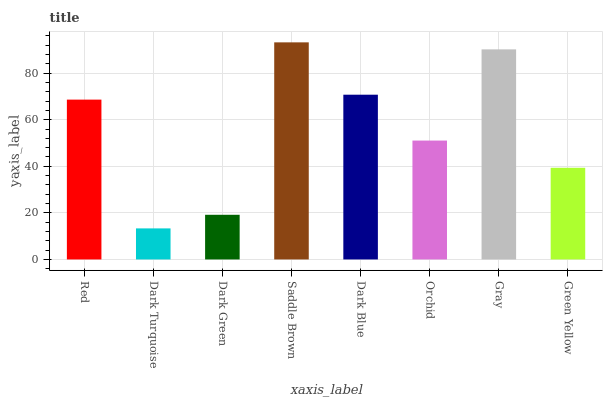Is Dark Turquoise the minimum?
Answer yes or no. Yes. Is Saddle Brown the maximum?
Answer yes or no. Yes. Is Dark Green the minimum?
Answer yes or no. No. Is Dark Green the maximum?
Answer yes or no. No. Is Dark Green greater than Dark Turquoise?
Answer yes or no. Yes. Is Dark Turquoise less than Dark Green?
Answer yes or no. Yes. Is Dark Turquoise greater than Dark Green?
Answer yes or no. No. Is Dark Green less than Dark Turquoise?
Answer yes or no. No. Is Red the high median?
Answer yes or no. Yes. Is Orchid the low median?
Answer yes or no. Yes. Is Dark Blue the high median?
Answer yes or no. No. Is Saddle Brown the low median?
Answer yes or no. No. 